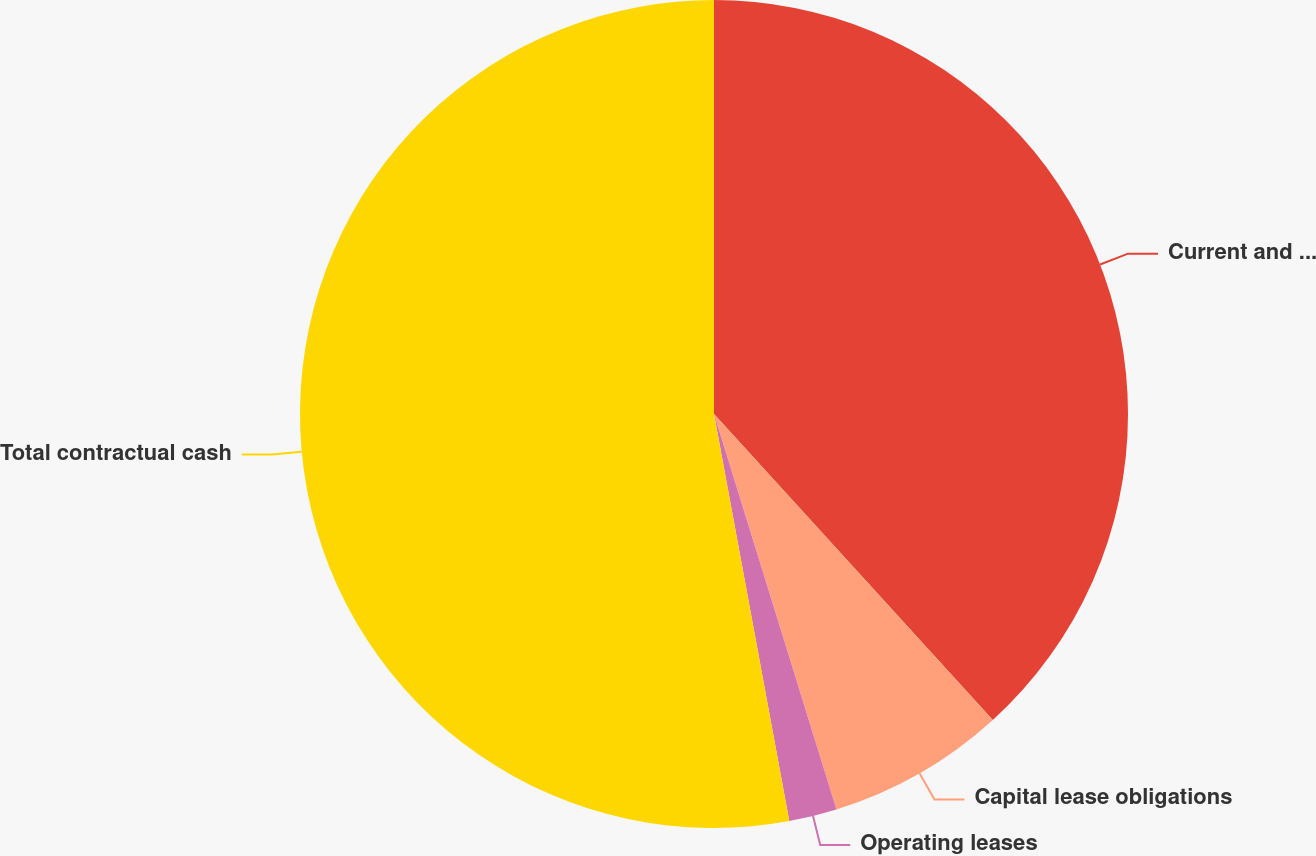Convert chart. <chart><loc_0><loc_0><loc_500><loc_500><pie_chart><fcel>Current and long-term debt<fcel>Capital lease obligations<fcel>Operating leases<fcel>Total contractual cash<nl><fcel>38.24%<fcel>6.98%<fcel>1.87%<fcel>52.91%<nl></chart> 